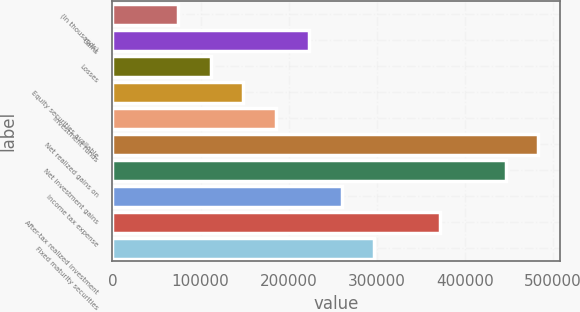<chart> <loc_0><loc_0><loc_500><loc_500><bar_chart><fcel>(In thousands)<fcel>Gains<fcel>Losses<fcel>Equity securities available<fcel>Investment funds<fcel>Net realized gains on<fcel>Net investment gains<fcel>Income tax expense<fcel>After-tax realized investment<fcel>Fixed maturity securities<nl><fcel>74390.2<fcel>223053<fcel>111556<fcel>148721<fcel>185887<fcel>483212<fcel>446046<fcel>260218<fcel>371715<fcel>297384<nl></chart> 